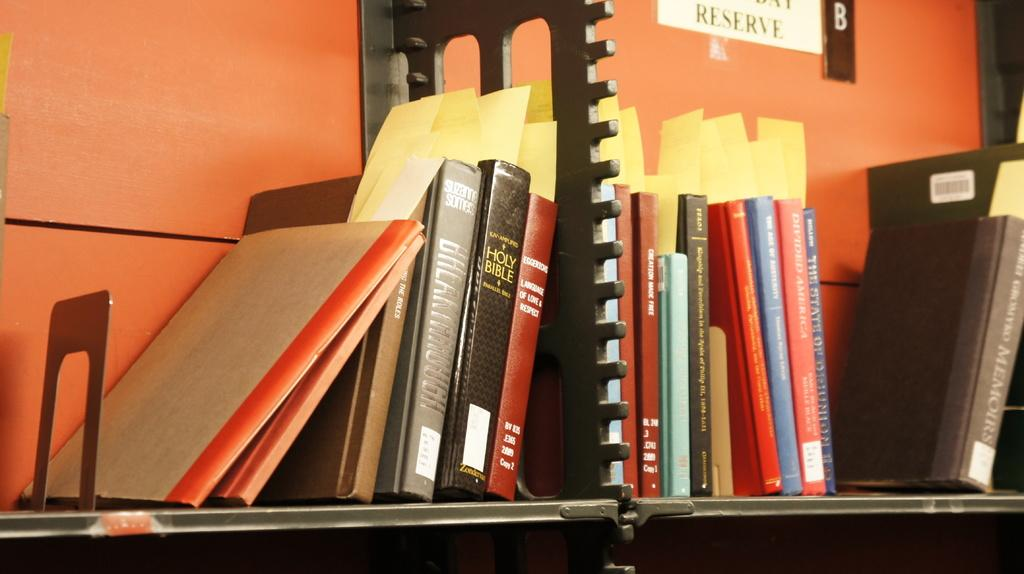<image>
Share a concise interpretation of the image provided. Many books on a shelf including the Holy Bible. 